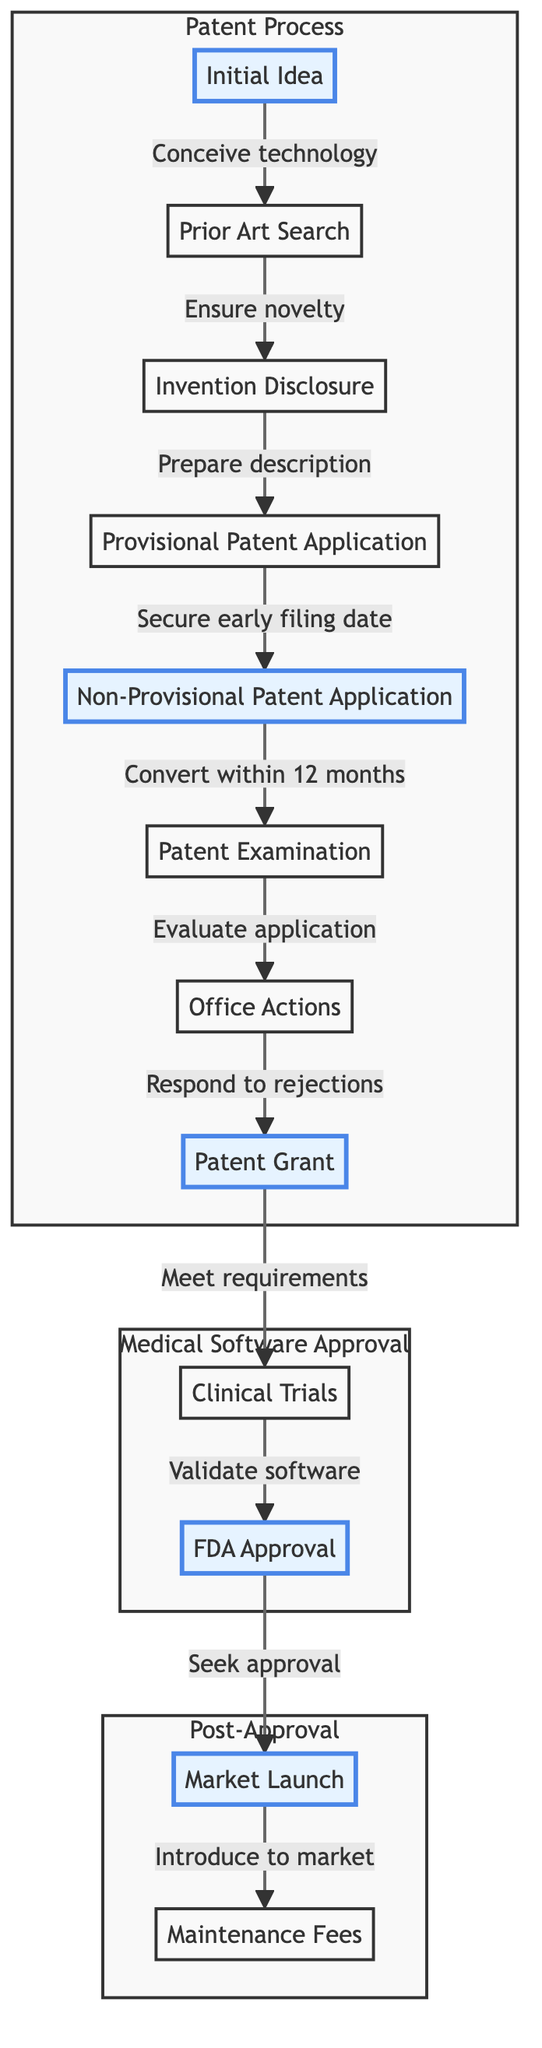What's the starting point of the patent process? The diagram indicates 'Initial Idea' as the starting point, as it is the first node in the flow of the diagram.
Answer: Initial Idea What follows the 'Prior Art Search'? The flow shows that 'Invention Disclosure' directly follows 'Prior Art Search', as it is the next step in the process.
Answer: Invention Disclosure How many main sections are there in the diagram? By analyzing the diagram, there are three main sections labeled as 'Patent Process', 'Medical Software Approval', and 'Post-Approval', which totals three sections.
Answer: 3 What is the last step before 'Market Launch'? According to the diagram, 'FDA Approval' is the step that occurs immediately before 'Market Launch'.
Answer: FDA Approval What action occurs after 'Office Actions'? The diagram indicates that the action that follows 'Office Actions' is 'Patent Grant', making it the next step in the process.
Answer: Patent Grant What is the relationship between 'Clinical Trials' and 'FDA Approval'? The flow indicates that 'FDA Approval' follows 'Clinical Trials', showing a sequential relationship where the completion of trials leads to seeking FDA approval.
Answer: Sequential Which node is emphasized as a bold step in the process? The diagram highlights both 'Initial Idea' and 'Market Launch' by making them bold, indicating these steps are significant in the overall process.
Answer: Initial Idea, Market Launch How many nodes are involved in the 'Patent Process'? By examining the nodes within the 'Patent Process' section, there are a total of seven nodes that describe various stages of patent application and examination.
Answer: 7 What is required before filing a non-provisional patent application? The flow specifies that 'Provisional Patent Application' must be filed first to secure an early filing date before submitting a non-provisional application.
Answer: Provisional Patent Application 